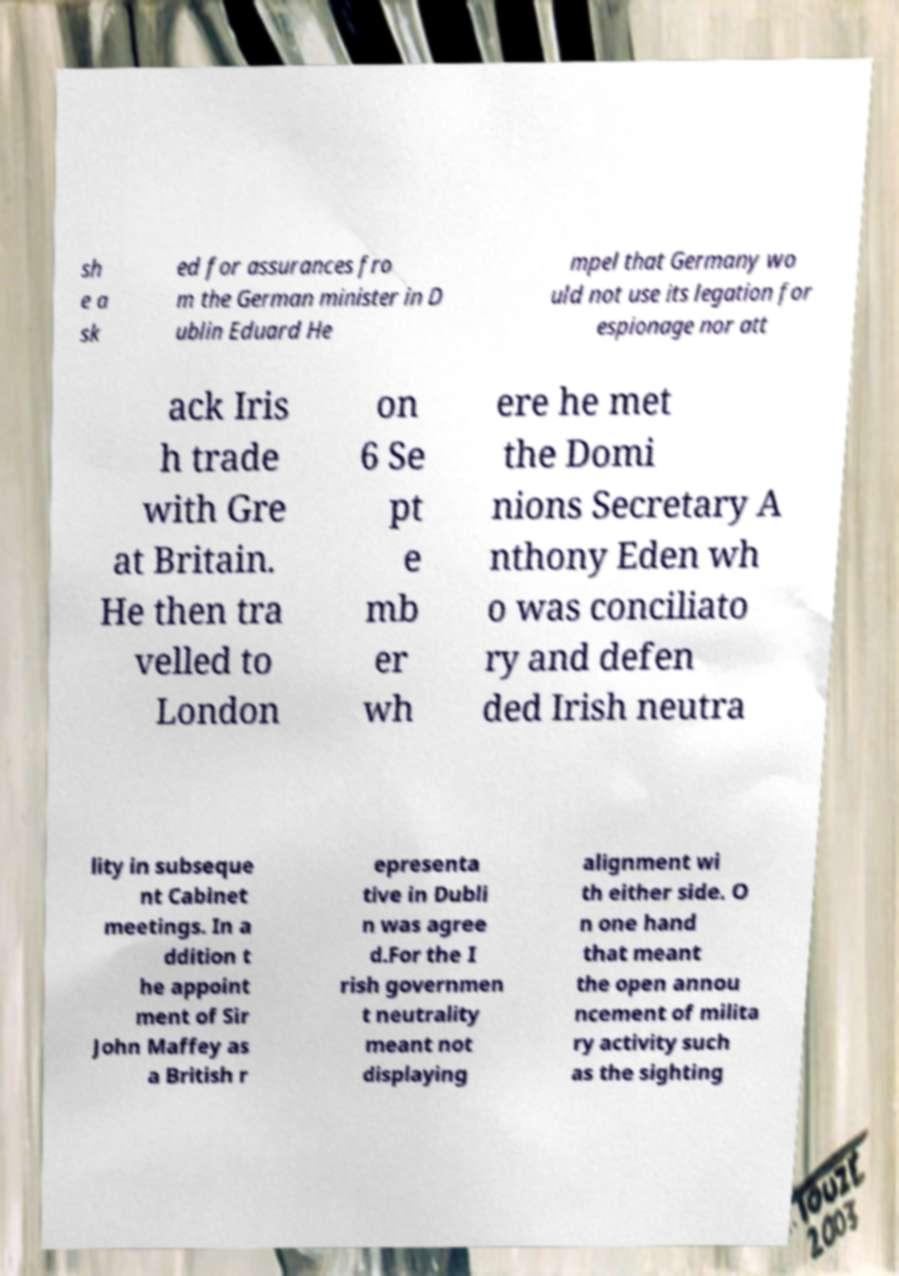I need the written content from this picture converted into text. Can you do that? sh e a sk ed for assurances fro m the German minister in D ublin Eduard He mpel that Germany wo uld not use its legation for espionage nor att ack Iris h trade with Gre at Britain. He then tra velled to London on 6 Se pt e mb er wh ere he met the Domi nions Secretary A nthony Eden wh o was conciliato ry and defen ded Irish neutra lity in subseque nt Cabinet meetings. In a ddition t he appoint ment of Sir John Maffey as a British r epresenta tive in Dubli n was agree d.For the I rish governmen t neutrality meant not displaying alignment wi th either side. O n one hand that meant the open annou ncement of milita ry activity such as the sighting 